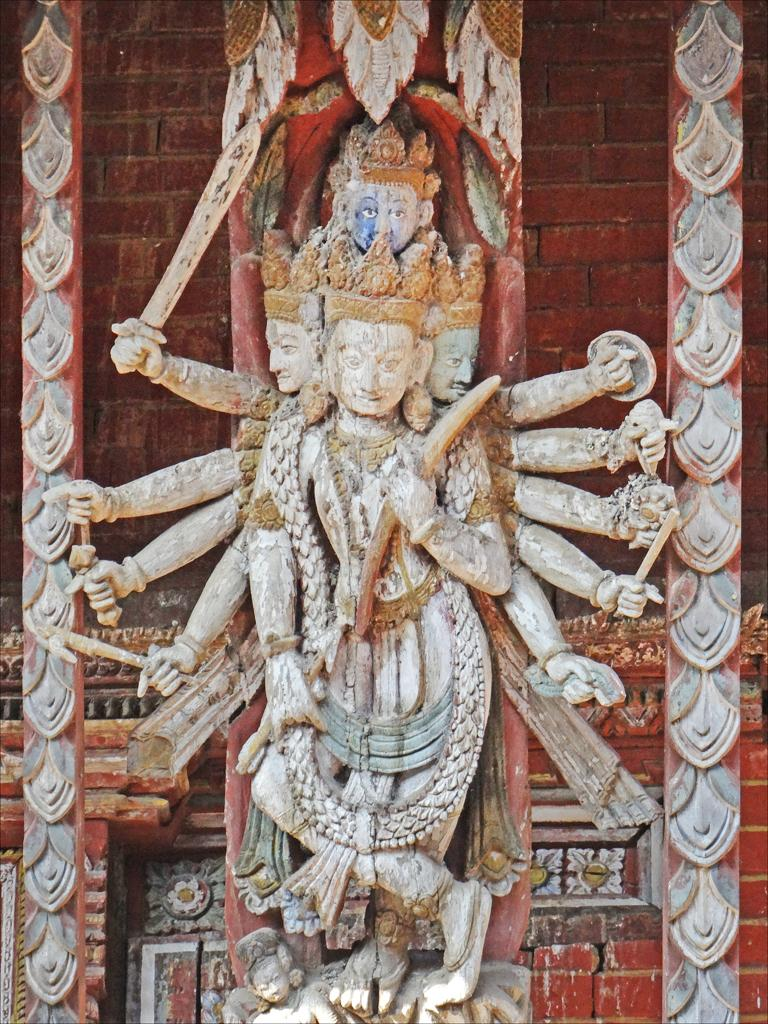What is the main subject of the image? There is a sculpture of a god in the image. What can be seen on the pillars on either side of the sculpture? There are designs carved on the pillars on the left and right sides of the image. What is visible in the background of the image? There is a wall in the background of the image. What type of blood vessels can be seen in the image? There is no reference to blood vessels or any biological elements in the image; it features a sculpture of a god with carved designs on pillars and a wall in the background. 